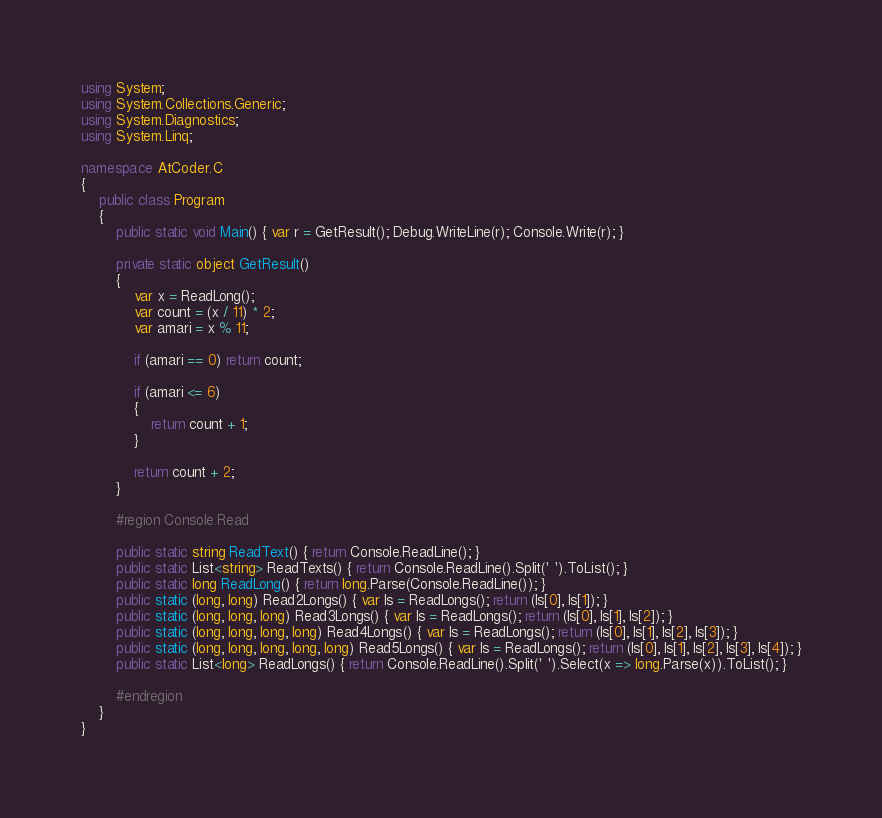Convert code to text. <code><loc_0><loc_0><loc_500><loc_500><_C#_>using System;
using System.Collections.Generic;
using System.Diagnostics;
using System.Linq;

namespace AtCoder.C
{
    public class Program
    {
        public static void Main() { var r = GetResult(); Debug.WriteLine(r); Console.Write(r); }

        private static object GetResult()
        {
            var x = ReadLong();
            var count = (x / 11) * 2;
            var amari = x % 11;

            if (amari == 0) return count;

            if (amari <= 6)
            {
                return count + 1;
            }

            return count + 2;
        }

        #region Console.Read

        public static string ReadText() { return Console.ReadLine(); }
        public static List<string> ReadTexts() { return Console.ReadLine().Split(' ').ToList(); }
        public static long ReadLong() { return long.Parse(Console.ReadLine()); }
        public static (long, long) Read2Longs() { var ls = ReadLongs(); return (ls[0], ls[1]); }
        public static (long, long, long) Read3Longs() { var ls = ReadLongs(); return (ls[0], ls[1], ls[2]); }
        public static (long, long, long, long) Read4Longs() { var ls = ReadLongs(); return (ls[0], ls[1], ls[2], ls[3]); }
        public static (long, long, long, long, long) Read5Longs() { var ls = ReadLongs(); return (ls[0], ls[1], ls[2], ls[3], ls[4]); }
        public static List<long> ReadLongs() { return Console.ReadLine().Split(' ').Select(x => long.Parse(x)).ToList(); }

        #endregion
    }
}
</code> 